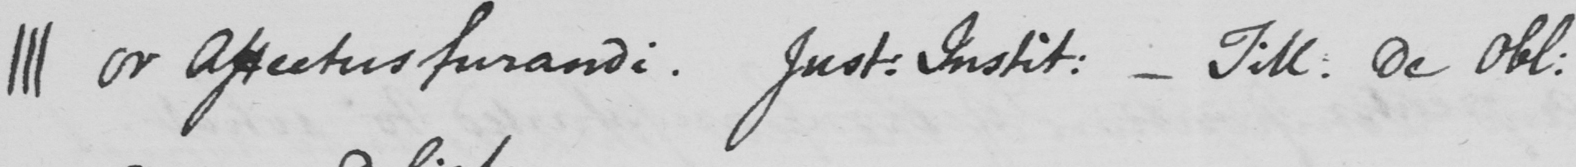What does this handwritten line say? ||| or affectus furandi Just . Instit :   _  Till . de obl : 